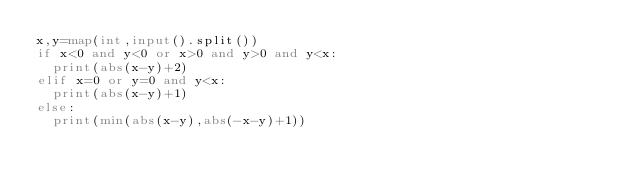<code> <loc_0><loc_0><loc_500><loc_500><_Python_>x,y=map(int,input().split())
if x<0 and y<0 or x>0 and y>0 and y<x:
  print(abs(x-y)+2)
elif x=0 or y=0 and y<x:
  print(abs(x-y)+1)
else:
  print(min(abs(x-y),abs(-x-y)+1))
</code> 